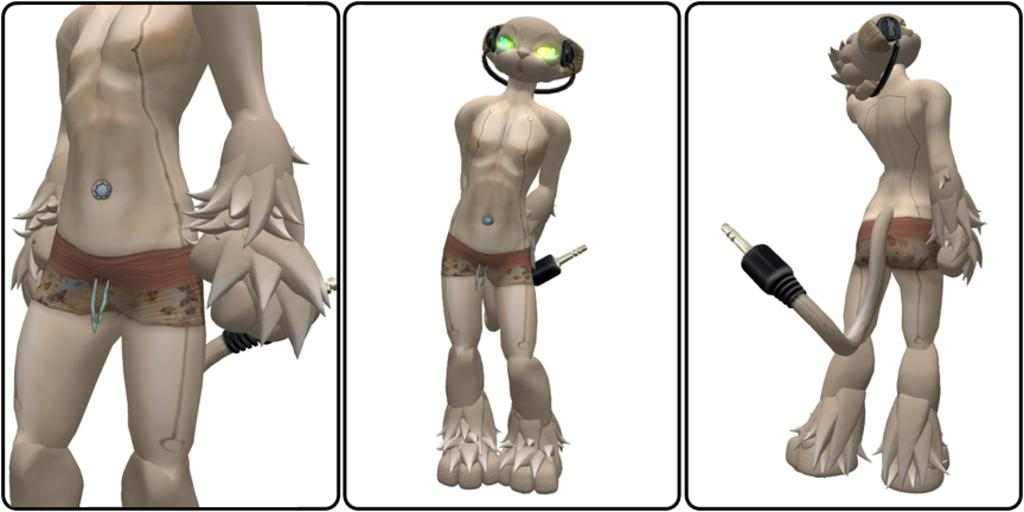What type of image is being described? The image is animated. Can you describe the animal-like object in the image? There is an object that resembles an animal in the image, and it is wearing headphones. What color is the background of the image? The background of the image is white. What type of shirt is the animal-like object wearing in the image? There is no shirt visible on the animal-like object in the image. Can you describe the nest that the animal-like object is sitting on in the image? There is no nest present in the image; the animal-like object is not sitting on anything. 